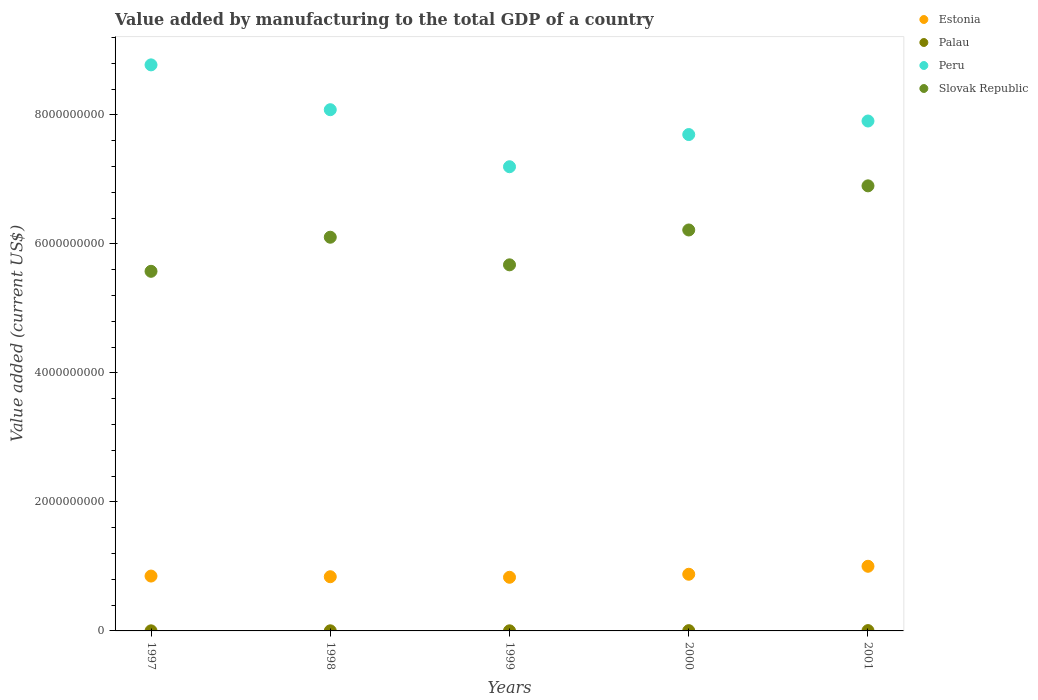Is the number of dotlines equal to the number of legend labels?
Provide a short and direct response. Yes. What is the value added by manufacturing to the total GDP in Peru in 1999?
Give a very brief answer. 7.20e+09. Across all years, what is the maximum value added by manufacturing to the total GDP in Palau?
Your answer should be very brief. 4.91e+06. Across all years, what is the minimum value added by manufacturing to the total GDP in Peru?
Keep it short and to the point. 7.20e+09. What is the total value added by manufacturing to the total GDP in Slovak Republic in the graph?
Make the answer very short. 3.05e+1. What is the difference between the value added by manufacturing to the total GDP in Palau in 1997 and that in 2000?
Offer a terse response. -2.79e+06. What is the difference between the value added by manufacturing to the total GDP in Slovak Republic in 1997 and the value added by manufacturing to the total GDP in Palau in 2000?
Offer a terse response. 5.57e+09. What is the average value added by manufacturing to the total GDP in Peru per year?
Your answer should be very brief. 7.93e+09. In the year 1998, what is the difference between the value added by manufacturing to the total GDP in Estonia and value added by manufacturing to the total GDP in Palau?
Ensure brevity in your answer.  8.39e+08. What is the ratio of the value added by manufacturing to the total GDP in Slovak Republic in 1998 to that in 2001?
Provide a succinct answer. 0.88. Is the value added by manufacturing to the total GDP in Peru in 1998 less than that in 2001?
Your response must be concise. No. What is the difference between the highest and the second highest value added by manufacturing to the total GDP in Peru?
Provide a short and direct response. 6.95e+08. What is the difference between the highest and the lowest value added by manufacturing to the total GDP in Palau?
Your response must be concise. 3.51e+06. Is the sum of the value added by manufacturing to the total GDP in Estonia in 1999 and 2000 greater than the maximum value added by manufacturing to the total GDP in Palau across all years?
Keep it short and to the point. Yes. Does the value added by manufacturing to the total GDP in Slovak Republic monotonically increase over the years?
Make the answer very short. No. Is the value added by manufacturing to the total GDP in Estonia strictly less than the value added by manufacturing to the total GDP in Peru over the years?
Provide a succinct answer. Yes. How many dotlines are there?
Offer a terse response. 4. Does the graph contain any zero values?
Your response must be concise. No. Where does the legend appear in the graph?
Make the answer very short. Top right. How are the legend labels stacked?
Your response must be concise. Vertical. What is the title of the graph?
Make the answer very short. Value added by manufacturing to the total GDP of a country. What is the label or title of the Y-axis?
Offer a very short reply. Value added (current US$). What is the Value added (current US$) in Estonia in 1997?
Make the answer very short. 8.51e+08. What is the Value added (current US$) of Palau in 1997?
Offer a very short reply. 1.40e+06. What is the Value added (current US$) of Peru in 1997?
Offer a terse response. 8.78e+09. What is the Value added (current US$) in Slovak Republic in 1997?
Offer a very short reply. 5.58e+09. What is the Value added (current US$) in Estonia in 1998?
Make the answer very short. 8.40e+08. What is the Value added (current US$) in Palau in 1998?
Provide a succinct answer. 1.70e+06. What is the Value added (current US$) of Peru in 1998?
Offer a terse response. 8.08e+09. What is the Value added (current US$) in Slovak Republic in 1998?
Ensure brevity in your answer.  6.10e+09. What is the Value added (current US$) of Estonia in 1999?
Your response must be concise. 8.32e+08. What is the Value added (current US$) in Palau in 1999?
Ensure brevity in your answer.  1.61e+06. What is the Value added (current US$) of Peru in 1999?
Provide a succinct answer. 7.20e+09. What is the Value added (current US$) of Slovak Republic in 1999?
Offer a very short reply. 5.68e+09. What is the Value added (current US$) in Estonia in 2000?
Your answer should be compact. 8.79e+08. What is the Value added (current US$) in Palau in 2000?
Provide a short and direct response. 4.19e+06. What is the Value added (current US$) in Peru in 2000?
Make the answer very short. 7.70e+09. What is the Value added (current US$) in Slovak Republic in 2000?
Your answer should be compact. 6.22e+09. What is the Value added (current US$) of Estonia in 2001?
Make the answer very short. 1.00e+09. What is the Value added (current US$) of Palau in 2001?
Give a very brief answer. 4.91e+06. What is the Value added (current US$) in Peru in 2001?
Provide a short and direct response. 7.91e+09. What is the Value added (current US$) in Slovak Republic in 2001?
Offer a terse response. 6.90e+09. Across all years, what is the maximum Value added (current US$) in Estonia?
Make the answer very short. 1.00e+09. Across all years, what is the maximum Value added (current US$) in Palau?
Provide a succinct answer. 4.91e+06. Across all years, what is the maximum Value added (current US$) of Peru?
Provide a succinct answer. 8.78e+09. Across all years, what is the maximum Value added (current US$) in Slovak Republic?
Make the answer very short. 6.90e+09. Across all years, what is the minimum Value added (current US$) of Estonia?
Keep it short and to the point. 8.32e+08. Across all years, what is the minimum Value added (current US$) of Palau?
Your response must be concise. 1.40e+06. Across all years, what is the minimum Value added (current US$) of Peru?
Offer a very short reply. 7.20e+09. Across all years, what is the minimum Value added (current US$) of Slovak Republic?
Ensure brevity in your answer.  5.58e+09. What is the total Value added (current US$) of Estonia in the graph?
Keep it short and to the point. 4.40e+09. What is the total Value added (current US$) in Palau in the graph?
Make the answer very short. 1.38e+07. What is the total Value added (current US$) in Peru in the graph?
Provide a succinct answer. 3.97e+1. What is the total Value added (current US$) in Slovak Republic in the graph?
Your answer should be very brief. 3.05e+1. What is the difference between the Value added (current US$) of Estonia in 1997 and that in 1998?
Offer a very short reply. 1.03e+07. What is the difference between the Value added (current US$) in Palau in 1997 and that in 1998?
Give a very brief answer. -2.99e+05. What is the difference between the Value added (current US$) in Peru in 1997 and that in 1998?
Your answer should be compact. 6.95e+08. What is the difference between the Value added (current US$) of Slovak Republic in 1997 and that in 1998?
Your response must be concise. -5.29e+08. What is the difference between the Value added (current US$) of Estonia in 1997 and that in 1999?
Your answer should be compact. 1.89e+07. What is the difference between the Value added (current US$) of Palau in 1997 and that in 1999?
Provide a succinct answer. -2.06e+05. What is the difference between the Value added (current US$) in Peru in 1997 and that in 1999?
Your answer should be compact. 1.58e+09. What is the difference between the Value added (current US$) of Slovak Republic in 1997 and that in 1999?
Make the answer very short. -1.00e+08. What is the difference between the Value added (current US$) of Estonia in 1997 and that in 2000?
Provide a succinct answer. -2.80e+07. What is the difference between the Value added (current US$) in Palau in 1997 and that in 2000?
Make the answer very short. -2.79e+06. What is the difference between the Value added (current US$) of Peru in 1997 and that in 2000?
Provide a succinct answer. 1.08e+09. What is the difference between the Value added (current US$) of Slovak Republic in 1997 and that in 2000?
Your answer should be compact. -6.41e+08. What is the difference between the Value added (current US$) in Estonia in 1997 and that in 2001?
Provide a short and direct response. -1.52e+08. What is the difference between the Value added (current US$) in Palau in 1997 and that in 2001?
Ensure brevity in your answer.  -3.51e+06. What is the difference between the Value added (current US$) of Peru in 1997 and that in 2001?
Keep it short and to the point. 8.71e+08. What is the difference between the Value added (current US$) of Slovak Republic in 1997 and that in 2001?
Your answer should be very brief. -1.33e+09. What is the difference between the Value added (current US$) of Estonia in 1998 and that in 1999?
Your answer should be very brief. 8.65e+06. What is the difference between the Value added (current US$) of Palau in 1998 and that in 1999?
Provide a succinct answer. 9.30e+04. What is the difference between the Value added (current US$) of Peru in 1998 and that in 1999?
Offer a very short reply. 8.84e+08. What is the difference between the Value added (current US$) in Slovak Republic in 1998 and that in 1999?
Your response must be concise. 4.28e+08. What is the difference between the Value added (current US$) in Estonia in 1998 and that in 2000?
Offer a terse response. -3.83e+07. What is the difference between the Value added (current US$) in Palau in 1998 and that in 2000?
Ensure brevity in your answer.  -2.49e+06. What is the difference between the Value added (current US$) in Peru in 1998 and that in 2000?
Your answer should be very brief. 3.85e+08. What is the difference between the Value added (current US$) in Slovak Republic in 1998 and that in 2000?
Ensure brevity in your answer.  -1.12e+08. What is the difference between the Value added (current US$) in Estonia in 1998 and that in 2001?
Provide a succinct answer. -1.62e+08. What is the difference between the Value added (current US$) in Palau in 1998 and that in 2001?
Your answer should be very brief. -3.21e+06. What is the difference between the Value added (current US$) of Peru in 1998 and that in 2001?
Your response must be concise. 1.75e+08. What is the difference between the Value added (current US$) of Slovak Republic in 1998 and that in 2001?
Your response must be concise. -7.97e+08. What is the difference between the Value added (current US$) in Estonia in 1999 and that in 2000?
Ensure brevity in your answer.  -4.69e+07. What is the difference between the Value added (current US$) in Palau in 1999 and that in 2000?
Your response must be concise. -2.58e+06. What is the difference between the Value added (current US$) of Peru in 1999 and that in 2000?
Provide a succinct answer. -4.99e+08. What is the difference between the Value added (current US$) in Slovak Republic in 1999 and that in 2000?
Give a very brief answer. -5.41e+08. What is the difference between the Value added (current US$) of Estonia in 1999 and that in 2001?
Ensure brevity in your answer.  -1.71e+08. What is the difference between the Value added (current US$) in Palau in 1999 and that in 2001?
Give a very brief answer. -3.30e+06. What is the difference between the Value added (current US$) of Peru in 1999 and that in 2001?
Give a very brief answer. -7.09e+08. What is the difference between the Value added (current US$) in Slovak Republic in 1999 and that in 2001?
Your answer should be compact. -1.22e+09. What is the difference between the Value added (current US$) in Estonia in 2000 and that in 2001?
Offer a terse response. -1.24e+08. What is the difference between the Value added (current US$) in Palau in 2000 and that in 2001?
Provide a short and direct response. -7.20e+05. What is the difference between the Value added (current US$) of Peru in 2000 and that in 2001?
Offer a terse response. -2.10e+08. What is the difference between the Value added (current US$) in Slovak Republic in 2000 and that in 2001?
Keep it short and to the point. -6.84e+08. What is the difference between the Value added (current US$) in Estonia in 1997 and the Value added (current US$) in Palau in 1998?
Provide a succinct answer. 8.49e+08. What is the difference between the Value added (current US$) in Estonia in 1997 and the Value added (current US$) in Peru in 1998?
Your answer should be very brief. -7.23e+09. What is the difference between the Value added (current US$) of Estonia in 1997 and the Value added (current US$) of Slovak Republic in 1998?
Provide a short and direct response. -5.25e+09. What is the difference between the Value added (current US$) in Palau in 1997 and the Value added (current US$) in Peru in 1998?
Your answer should be compact. -8.08e+09. What is the difference between the Value added (current US$) of Palau in 1997 and the Value added (current US$) of Slovak Republic in 1998?
Provide a short and direct response. -6.10e+09. What is the difference between the Value added (current US$) in Peru in 1997 and the Value added (current US$) in Slovak Republic in 1998?
Provide a succinct answer. 2.67e+09. What is the difference between the Value added (current US$) of Estonia in 1997 and the Value added (current US$) of Palau in 1999?
Provide a succinct answer. 8.49e+08. What is the difference between the Value added (current US$) in Estonia in 1997 and the Value added (current US$) in Peru in 1999?
Keep it short and to the point. -6.35e+09. What is the difference between the Value added (current US$) of Estonia in 1997 and the Value added (current US$) of Slovak Republic in 1999?
Keep it short and to the point. -4.83e+09. What is the difference between the Value added (current US$) in Palau in 1997 and the Value added (current US$) in Peru in 1999?
Your response must be concise. -7.20e+09. What is the difference between the Value added (current US$) of Palau in 1997 and the Value added (current US$) of Slovak Republic in 1999?
Offer a very short reply. -5.68e+09. What is the difference between the Value added (current US$) of Peru in 1997 and the Value added (current US$) of Slovak Republic in 1999?
Ensure brevity in your answer.  3.10e+09. What is the difference between the Value added (current US$) in Estonia in 1997 and the Value added (current US$) in Palau in 2000?
Your answer should be very brief. 8.46e+08. What is the difference between the Value added (current US$) in Estonia in 1997 and the Value added (current US$) in Peru in 2000?
Provide a succinct answer. -6.85e+09. What is the difference between the Value added (current US$) in Estonia in 1997 and the Value added (current US$) in Slovak Republic in 2000?
Make the answer very short. -5.37e+09. What is the difference between the Value added (current US$) of Palau in 1997 and the Value added (current US$) of Peru in 2000?
Keep it short and to the point. -7.70e+09. What is the difference between the Value added (current US$) of Palau in 1997 and the Value added (current US$) of Slovak Republic in 2000?
Make the answer very short. -6.22e+09. What is the difference between the Value added (current US$) of Peru in 1997 and the Value added (current US$) of Slovak Republic in 2000?
Offer a terse response. 2.56e+09. What is the difference between the Value added (current US$) of Estonia in 1997 and the Value added (current US$) of Palau in 2001?
Your answer should be compact. 8.46e+08. What is the difference between the Value added (current US$) in Estonia in 1997 and the Value added (current US$) in Peru in 2001?
Your response must be concise. -7.06e+09. What is the difference between the Value added (current US$) of Estonia in 1997 and the Value added (current US$) of Slovak Republic in 2001?
Your response must be concise. -6.05e+09. What is the difference between the Value added (current US$) of Palau in 1997 and the Value added (current US$) of Peru in 2001?
Your response must be concise. -7.91e+09. What is the difference between the Value added (current US$) in Palau in 1997 and the Value added (current US$) in Slovak Republic in 2001?
Provide a succinct answer. -6.90e+09. What is the difference between the Value added (current US$) in Peru in 1997 and the Value added (current US$) in Slovak Republic in 2001?
Your answer should be very brief. 1.88e+09. What is the difference between the Value added (current US$) of Estonia in 1998 and the Value added (current US$) of Palau in 1999?
Provide a short and direct response. 8.39e+08. What is the difference between the Value added (current US$) in Estonia in 1998 and the Value added (current US$) in Peru in 1999?
Offer a terse response. -6.36e+09. What is the difference between the Value added (current US$) in Estonia in 1998 and the Value added (current US$) in Slovak Republic in 1999?
Give a very brief answer. -4.84e+09. What is the difference between the Value added (current US$) in Palau in 1998 and the Value added (current US$) in Peru in 1999?
Ensure brevity in your answer.  -7.20e+09. What is the difference between the Value added (current US$) in Palau in 1998 and the Value added (current US$) in Slovak Republic in 1999?
Give a very brief answer. -5.67e+09. What is the difference between the Value added (current US$) in Peru in 1998 and the Value added (current US$) in Slovak Republic in 1999?
Make the answer very short. 2.41e+09. What is the difference between the Value added (current US$) in Estonia in 1998 and the Value added (current US$) in Palau in 2000?
Make the answer very short. 8.36e+08. What is the difference between the Value added (current US$) in Estonia in 1998 and the Value added (current US$) in Peru in 2000?
Keep it short and to the point. -6.86e+09. What is the difference between the Value added (current US$) of Estonia in 1998 and the Value added (current US$) of Slovak Republic in 2000?
Offer a terse response. -5.38e+09. What is the difference between the Value added (current US$) of Palau in 1998 and the Value added (current US$) of Peru in 2000?
Your answer should be very brief. -7.69e+09. What is the difference between the Value added (current US$) of Palau in 1998 and the Value added (current US$) of Slovak Republic in 2000?
Offer a terse response. -6.22e+09. What is the difference between the Value added (current US$) in Peru in 1998 and the Value added (current US$) in Slovak Republic in 2000?
Offer a very short reply. 1.86e+09. What is the difference between the Value added (current US$) of Estonia in 1998 and the Value added (current US$) of Palau in 2001?
Provide a succinct answer. 8.35e+08. What is the difference between the Value added (current US$) of Estonia in 1998 and the Value added (current US$) of Peru in 2001?
Offer a very short reply. -7.07e+09. What is the difference between the Value added (current US$) in Estonia in 1998 and the Value added (current US$) in Slovak Republic in 2001?
Ensure brevity in your answer.  -6.06e+09. What is the difference between the Value added (current US$) in Palau in 1998 and the Value added (current US$) in Peru in 2001?
Keep it short and to the point. -7.90e+09. What is the difference between the Value added (current US$) in Palau in 1998 and the Value added (current US$) in Slovak Republic in 2001?
Offer a very short reply. -6.90e+09. What is the difference between the Value added (current US$) of Peru in 1998 and the Value added (current US$) of Slovak Republic in 2001?
Provide a short and direct response. 1.18e+09. What is the difference between the Value added (current US$) of Estonia in 1999 and the Value added (current US$) of Palau in 2000?
Ensure brevity in your answer.  8.28e+08. What is the difference between the Value added (current US$) in Estonia in 1999 and the Value added (current US$) in Peru in 2000?
Offer a terse response. -6.86e+09. What is the difference between the Value added (current US$) in Estonia in 1999 and the Value added (current US$) in Slovak Republic in 2000?
Provide a succinct answer. -5.39e+09. What is the difference between the Value added (current US$) of Palau in 1999 and the Value added (current US$) of Peru in 2000?
Your response must be concise. -7.70e+09. What is the difference between the Value added (current US$) in Palau in 1999 and the Value added (current US$) in Slovak Republic in 2000?
Offer a terse response. -6.22e+09. What is the difference between the Value added (current US$) of Peru in 1999 and the Value added (current US$) of Slovak Republic in 2000?
Keep it short and to the point. 9.81e+08. What is the difference between the Value added (current US$) in Estonia in 1999 and the Value added (current US$) in Palau in 2001?
Ensure brevity in your answer.  8.27e+08. What is the difference between the Value added (current US$) of Estonia in 1999 and the Value added (current US$) of Peru in 2001?
Offer a very short reply. -7.07e+09. What is the difference between the Value added (current US$) of Estonia in 1999 and the Value added (current US$) of Slovak Republic in 2001?
Your answer should be very brief. -6.07e+09. What is the difference between the Value added (current US$) of Palau in 1999 and the Value added (current US$) of Peru in 2001?
Keep it short and to the point. -7.90e+09. What is the difference between the Value added (current US$) in Palau in 1999 and the Value added (current US$) in Slovak Republic in 2001?
Ensure brevity in your answer.  -6.90e+09. What is the difference between the Value added (current US$) of Peru in 1999 and the Value added (current US$) of Slovak Republic in 2001?
Offer a terse response. 2.96e+08. What is the difference between the Value added (current US$) in Estonia in 2000 and the Value added (current US$) in Palau in 2001?
Provide a short and direct response. 8.74e+08. What is the difference between the Value added (current US$) of Estonia in 2000 and the Value added (current US$) of Peru in 2001?
Ensure brevity in your answer.  -7.03e+09. What is the difference between the Value added (current US$) in Estonia in 2000 and the Value added (current US$) in Slovak Republic in 2001?
Your answer should be compact. -6.02e+09. What is the difference between the Value added (current US$) of Palau in 2000 and the Value added (current US$) of Peru in 2001?
Ensure brevity in your answer.  -7.90e+09. What is the difference between the Value added (current US$) of Palau in 2000 and the Value added (current US$) of Slovak Republic in 2001?
Offer a very short reply. -6.90e+09. What is the difference between the Value added (current US$) in Peru in 2000 and the Value added (current US$) in Slovak Republic in 2001?
Provide a short and direct response. 7.95e+08. What is the average Value added (current US$) in Estonia per year?
Make the answer very short. 8.81e+08. What is the average Value added (current US$) of Palau per year?
Your answer should be compact. 2.76e+06. What is the average Value added (current US$) in Peru per year?
Keep it short and to the point. 7.93e+09. What is the average Value added (current US$) of Slovak Republic per year?
Your response must be concise. 6.10e+09. In the year 1997, what is the difference between the Value added (current US$) of Estonia and Value added (current US$) of Palau?
Offer a very short reply. 8.49e+08. In the year 1997, what is the difference between the Value added (current US$) in Estonia and Value added (current US$) in Peru?
Your response must be concise. -7.93e+09. In the year 1997, what is the difference between the Value added (current US$) in Estonia and Value added (current US$) in Slovak Republic?
Offer a very short reply. -4.73e+09. In the year 1997, what is the difference between the Value added (current US$) in Palau and Value added (current US$) in Peru?
Your answer should be compact. -8.78e+09. In the year 1997, what is the difference between the Value added (current US$) in Palau and Value added (current US$) in Slovak Republic?
Provide a succinct answer. -5.57e+09. In the year 1997, what is the difference between the Value added (current US$) in Peru and Value added (current US$) in Slovak Republic?
Provide a succinct answer. 3.20e+09. In the year 1998, what is the difference between the Value added (current US$) in Estonia and Value added (current US$) in Palau?
Give a very brief answer. 8.39e+08. In the year 1998, what is the difference between the Value added (current US$) of Estonia and Value added (current US$) of Peru?
Your response must be concise. -7.24e+09. In the year 1998, what is the difference between the Value added (current US$) in Estonia and Value added (current US$) in Slovak Republic?
Keep it short and to the point. -5.26e+09. In the year 1998, what is the difference between the Value added (current US$) of Palau and Value added (current US$) of Peru?
Provide a succinct answer. -8.08e+09. In the year 1998, what is the difference between the Value added (current US$) of Palau and Value added (current US$) of Slovak Republic?
Your answer should be very brief. -6.10e+09. In the year 1998, what is the difference between the Value added (current US$) of Peru and Value added (current US$) of Slovak Republic?
Give a very brief answer. 1.98e+09. In the year 1999, what is the difference between the Value added (current US$) in Estonia and Value added (current US$) in Palau?
Offer a terse response. 8.30e+08. In the year 1999, what is the difference between the Value added (current US$) of Estonia and Value added (current US$) of Peru?
Provide a short and direct response. -6.37e+09. In the year 1999, what is the difference between the Value added (current US$) of Estonia and Value added (current US$) of Slovak Republic?
Make the answer very short. -4.84e+09. In the year 1999, what is the difference between the Value added (current US$) in Palau and Value added (current US$) in Peru?
Provide a succinct answer. -7.20e+09. In the year 1999, what is the difference between the Value added (current US$) of Palau and Value added (current US$) of Slovak Republic?
Your response must be concise. -5.67e+09. In the year 1999, what is the difference between the Value added (current US$) in Peru and Value added (current US$) in Slovak Republic?
Make the answer very short. 1.52e+09. In the year 2000, what is the difference between the Value added (current US$) of Estonia and Value added (current US$) of Palau?
Your response must be concise. 8.74e+08. In the year 2000, what is the difference between the Value added (current US$) of Estonia and Value added (current US$) of Peru?
Your response must be concise. -6.82e+09. In the year 2000, what is the difference between the Value added (current US$) in Estonia and Value added (current US$) in Slovak Republic?
Provide a short and direct response. -5.34e+09. In the year 2000, what is the difference between the Value added (current US$) in Palau and Value added (current US$) in Peru?
Your answer should be compact. -7.69e+09. In the year 2000, what is the difference between the Value added (current US$) in Palau and Value added (current US$) in Slovak Republic?
Offer a very short reply. -6.21e+09. In the year 2000, what is the difference between the Value added (current US$) of Peru and Value added (current US$) of Slovak Republic?
Ensure brevity in your answer.  1.48e+09. In the year 2001, what is the difference between the Value added (current US$) in Estonia and Value added (current US$) in Palau?
Ensure brevity in your answer.  9.97e+08. In the year 2001, what is the difference between the Value added (current US$) in Estonia and Value added (current US$) in Peru?
Keep it short and to the point. -6.90e+09. In the year 2001, what is the difference between the Value added (current US$) of Estonia and Value added (current US$) of Slovak Republic?
Your answer should be very brief. -5.90e+09. In the year 2001, what is the difference between the Value added (current US$) of Palau and Value added (current US$) of Peru?
Your answer should be very brief. -7.90e+09. In the year 2001, what is the difference between the Value added (current US$) in Palau and Value added (current US$) in Slovak Republic?
Offer a very short reply. -6.90e+09. In the year 2001, what is the difference between the Value added (current US$) of Peru and Value added (current US$) of Slovak Republic?
Your response must be concise. 1.01e+09. What is the ratio of the Value added (current US$) of Estonia in 1997 to that in 1998?
Keep it short and to the point. 1.01. What is the ratio of the Value added (current US$) of Palau in 1997 to that in 1998?
Make the answer very short. 0.82. What is the ratio of the Value added (current US$) in Peru in 1997 to that in 1998?
Provide a short and direct response. 1.09. What is the ratio of the Value added (current US$) of Slovak Republic in 1997 to that in 1998?
Your answer should be very brief. 0.91. What is the ratio of the Value added (current US$) of Estonia in 1997 to that in 1999?
Make the answer very short. 1.02. What is the ratio of the Value added (current US$) of Palau in 1997 to that in 1999?
Ensure brevity in your answer.  0.87. What is the ratio of the Value added (current US$) of Peru in 1997 to that in 1999?
Make the answer very short. 1.22. What is the ratio of the Value added (current US$) in Slovak Republic in 1997 to that in 1999?
Offer a terse response. 0.98. What is the ratio of the Value added (current US$) in Estonia in 1997 to that in 2000?
Your answer should be very brief. 0.97. What is the ratio of the Value added (current US$) in Palau in 1997 to that in 2000?
Offer a very short reply. 0.34. What is the ratio of the Value added (current US$) of Peru in 1997 to that in 2000?
Give a very brief answer. 1.14. What is the ratio of the Value added (current US$) in Slovak Republic in 1997 to that in 2000?
Your answer should be very brief. 0.9. What is the ratio of the Value added (current US$) of Estonia in 1997 to that in 2001?
Make the answer very short. 0.85. What is the ratio of the Value added (current US$) in Palau in 1997 to that in 2001?
Your answer should be very brief. 0.29. What is the ratio of the Value added (current US$) in Peru in 1997 to that in 2001?
Provide a short and direct response. 1.11. What is the ratio of the Value added (current US$) in Slovak Republic in 1997 to that in 2001?
Keep it short and to the point. 0.81. What is the ratio of the Value added (current US$) in Estonia in 1998 to that in 1999?
Provide a short and direct response. 1.01. What is the ratio of the Value added (current US$) in Palau in 1998 to that in 1999?
Provide a short and direct response. 1.06. What is the ratio of the Value added (current US$) in Peru in 1998 to that in 1999?
Offer a very short reply. 1.12. What is the ratio of the Value added (current US$) of Slovak Republic in 1998 to that in 1999?
Offer a very short reply. 1.08. What is the ratio of the Value added (current US$) in Estonia in 1998 to that in 2000?
Your response must be concise. 0.96. What is the ratio of the Value added (current US$) in Palau in 1998 to that in 2000?
Provide a succinct answer. 0.41. What is the ratio of the Value added (current US$) in Peru in 1998 to that in 2000?
Your answer should be very brief. 1.05. What is the ratio of the Value added (current US$) in Slovak Republic in 1998 to that in 2000?
Offer a terse response. 0.98. What is the ratio of the Value added (current US$) of Estonia in 1998 to that in 2001?
Keep it short and to the point. 0.84. What is the ratio of the Value added (current US$) in Palau in 1998 to that in 2001?
Provide a short and direct response. 0.35. What is the ratio of the Value added (current US$) in Peru in 1998 to that in 2001?
Ensure brevity in your answer.  1.02. What is the ratio of the Value added (current US$) in Slovak Republic in 1998 to that in 2001?
Offer a terse response. 0.88. What is the ratio of the Value added (current US$) of Estonia in 1999 to that in 2000?
Your answer should be compact. 0.95. What is the ratio of the Value added (current US$) of Palau in 1999 to that in 2000?
Offer a terse response. 0.38. What is the ratio of the Value added (current US$) of Peru in 1999 to that in 2000?
Your response must be concise. 0.94. What is the ratio of the Value added (current US$) in Slovak Republic in 1999 to that in 2000?
Your response must be concise. 0.91. What is the ratio of the Value added (current US$) of Estonia in 1999 to that in 2001?
Provide a succinct answer. 0.83. What is the ratio of the Value added (current US$) in Palau in 1999 to that in 2001?
Your response must be concise. 0.33. What is the ratio of the Value added (current US$) of Peru in 1999 to that in 2001?
Give a very brief answer. 0.91. What is the ratio of the Value added (current US$) in Slovak Republic in 1999 to that in 2001?
Your response must be concise. 0.82. What is the ratio of the Value added (current US$) of Estonia in 2000 to that in 2001?
Provide a short and direct response. 0.88. What is the ratio of the Value added (current US$) in Palau in 2000 to that in 2001?
Your response must be concise. 0.85. What is the ratio of the Value added (current US$) of Peru in 2000 to that in 2001?
Offer a very short reply. 0.97. What is the ratio of the Value added (current US$) in Slovak Republic in 2000 to that in 2001?
Offer a very short reply. 0.9. What is the difference between the highest and the second highest Value added (current US$) of Estonia?
Ensure brevity in your answer.  1.24e+08. What is the difference between the highest and the second highest Value added (current US$) of Palau?
Your answer should be very brief. 7.20e+05. What is the difference between the highest and the second highest Value added (current US$) in Peru?
Offer a terse response. 6.95e+08. What is the difference between the highest and the second highest Value added (current US$) of Slovak Republic?
Make the answer very short. 6.84e+08. What is the difference between the highest and the lowest Value added (current US$) of Estonia?
Your response must be concise. 1.71e+08. What is the difference between the highest and the lowest Value added (current US$) in Palau?
Your answer should be compact. 3.51e+06. What is the difference between the highest and the lowest Value added (current US$) of Peru?
Keep it short and to the point. 1.58e+09. What is the difference between the highest and the lowest Value added (current US$) in Slovak Republic?
Ensure brevity in your answer.  1.33e+09. 